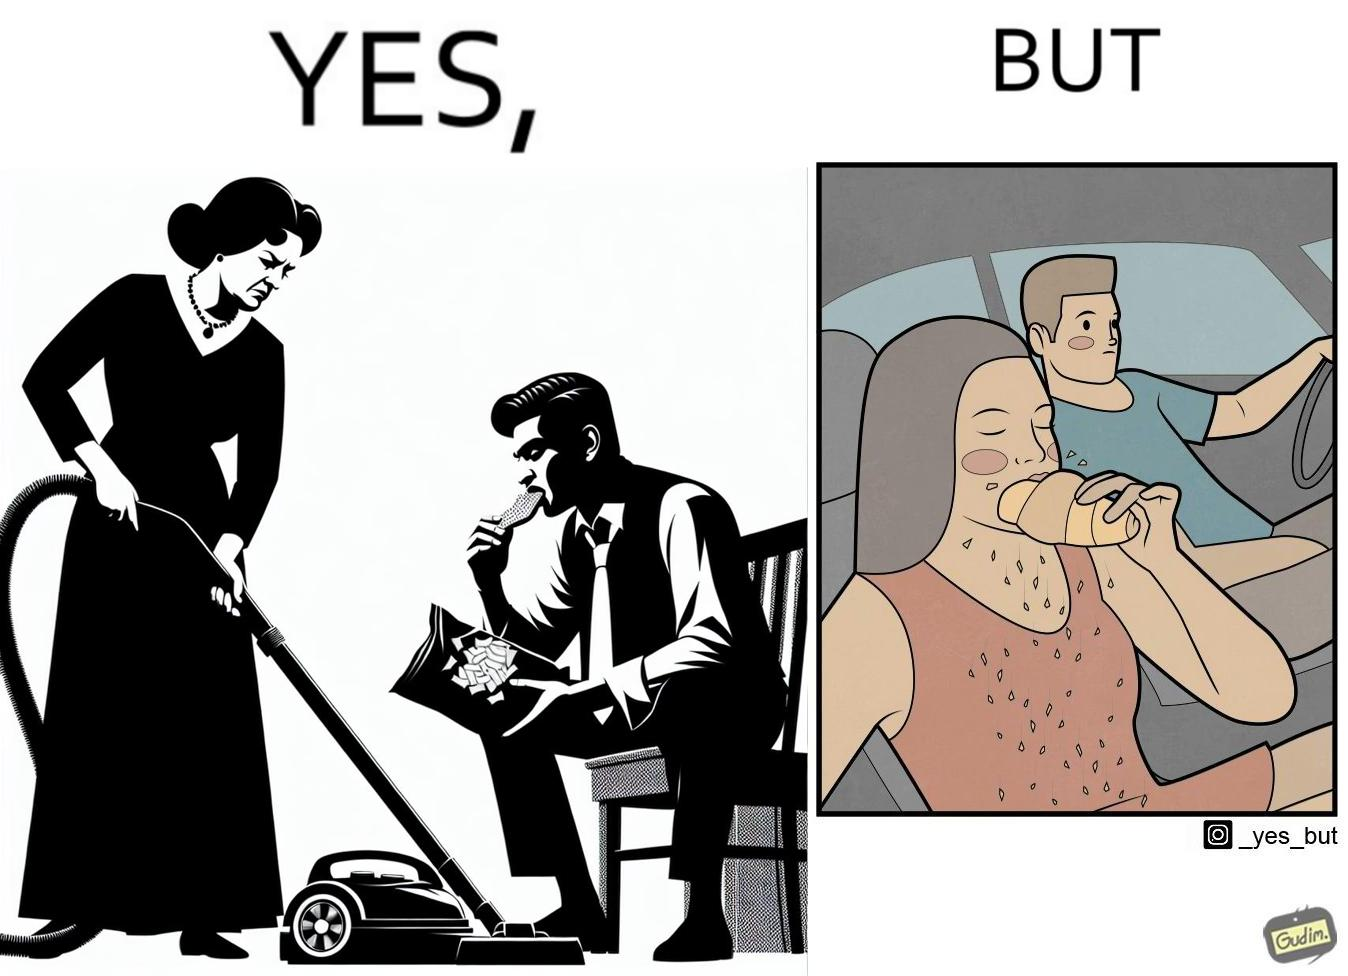What makes this image funny or satirical? The image is ironic, because in the left image she is seen how sincere she is about keeping her home clean but in the right image she forgets these principles while travelling in the car 